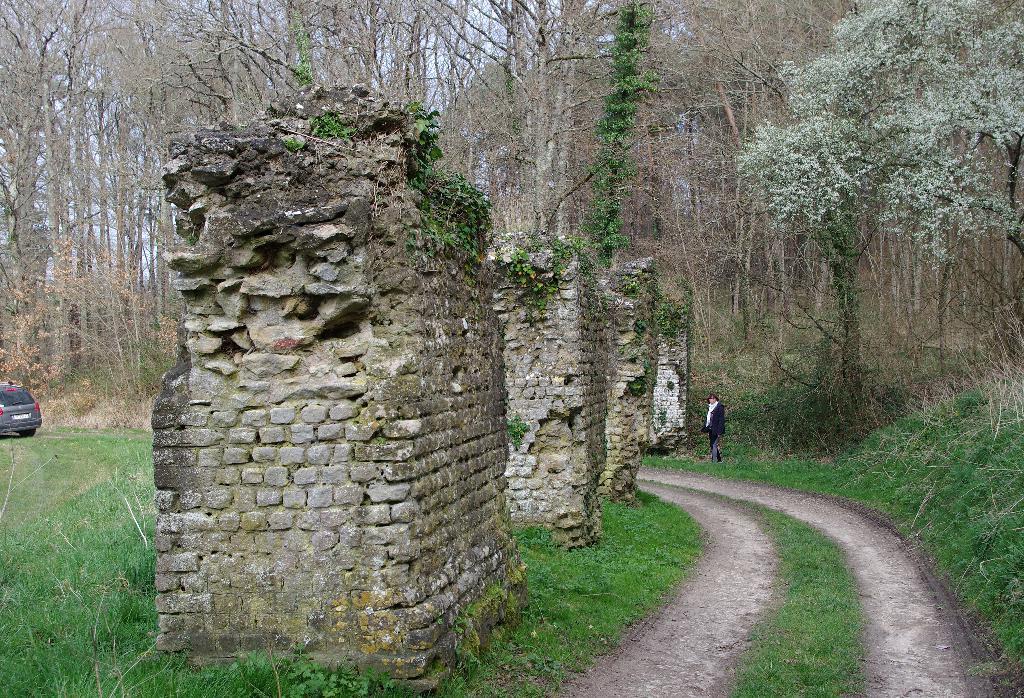In one or two sentences, can you explain what this image depicts? This is an outside view. Here I can see four walls. On the right side there is a path and one person is standing. On both sides of the path, I can see the grass on the ground. On the left side there is a car. In the background there are many trees. 